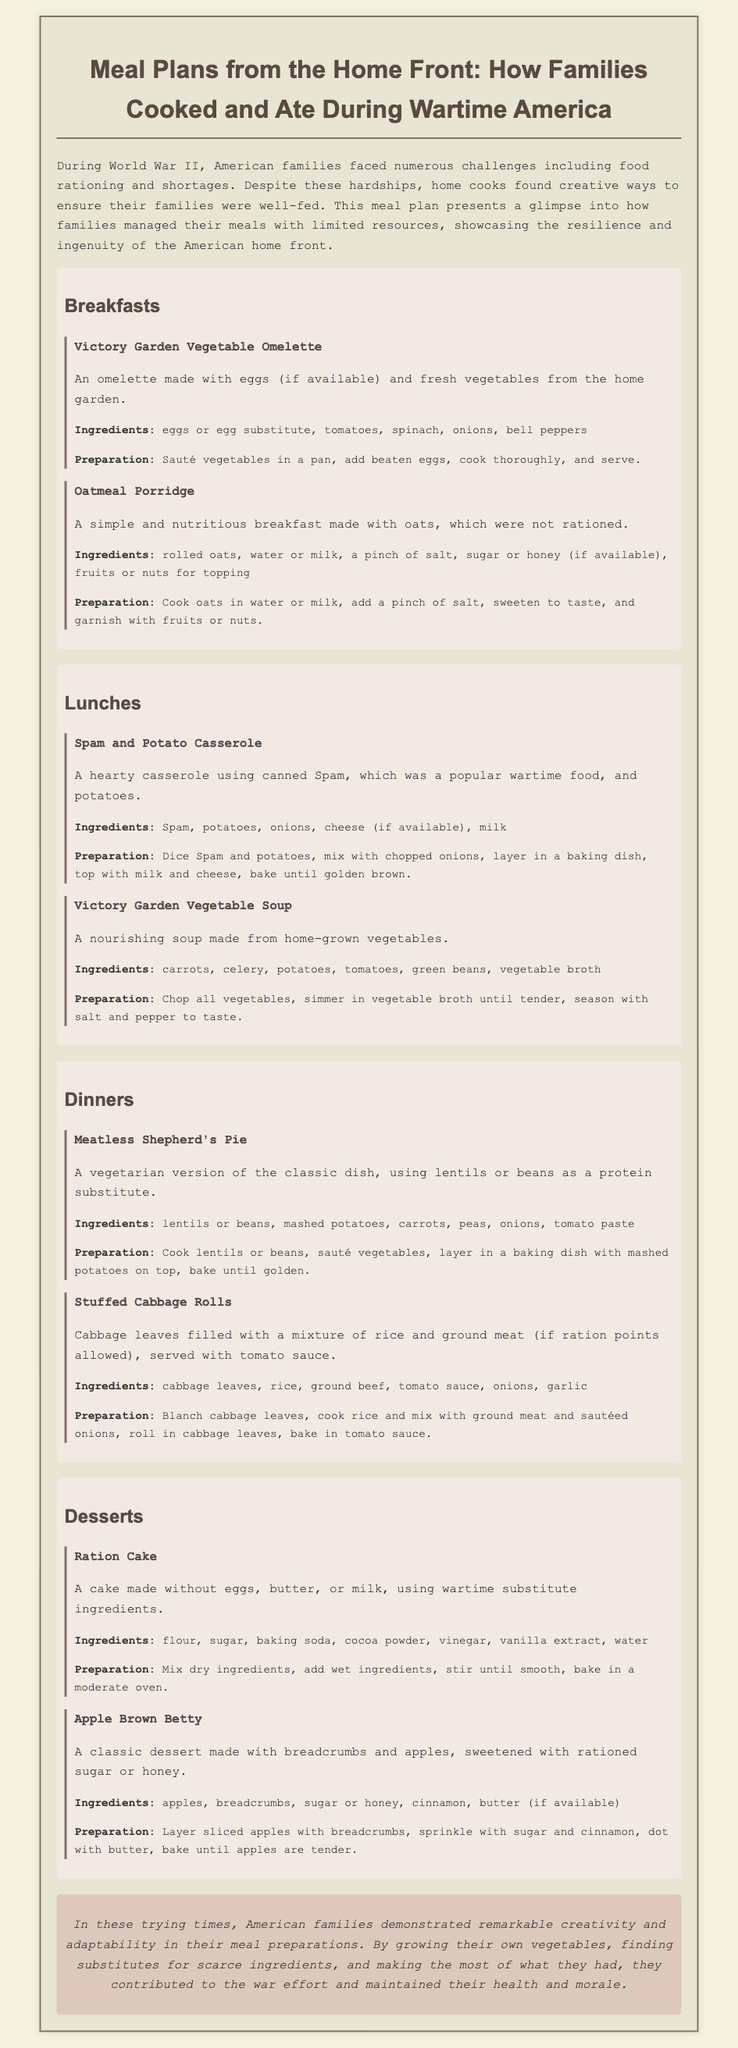What is the title of the document? The title of the document is given at the top of the rendered content, specifying the theme of the meal plans.
Answer: Meal Plans from the Home Front: How Families Cooked and Ate During Wartime America What type of dessert is mentioned first in the document? The dessert section lists the first dessert under the title 'Desserts', specifically highlighting its name and description.
Answer: Ration Cake What ingredients are used in the Victory Garden Vegetable Soup? By reading the ingredients section of the lunch meal, we can identify what is included in that dish.
Answer: carrots, celery, potatoes, tomatoes, green beans, vegetable broth How many breakfast items are included in the meal plan? The document lists the total number of breakfasts provided in a section dedicated to breakfast meals, which counts them explicitly.
Answer: 2 What is a primary ingredient in the Stuffed Cabbage Rolls? The list of ingredients under the dinner item will point directly to the main component of this meal.
Answer: cabbage leaves What does the preparation of Oatmeal Porridge require as a cooking liquid? The preparation instructions for this breakfast dish describe the necessary liquid for cooking.
Answer: water or milk Why did families need to adapt their meal preparations during wartime? The introduction explains the challenges faced by families during World War II that influenced their cooking methods.
Answer: food rationing and shortages Which meal plan section features a vegetarian dish? A careful review of the dinner section will reveal which specific dish is noted for being meatless, highlighting its nature.
Answer: Meatless Shepherd's Pie 